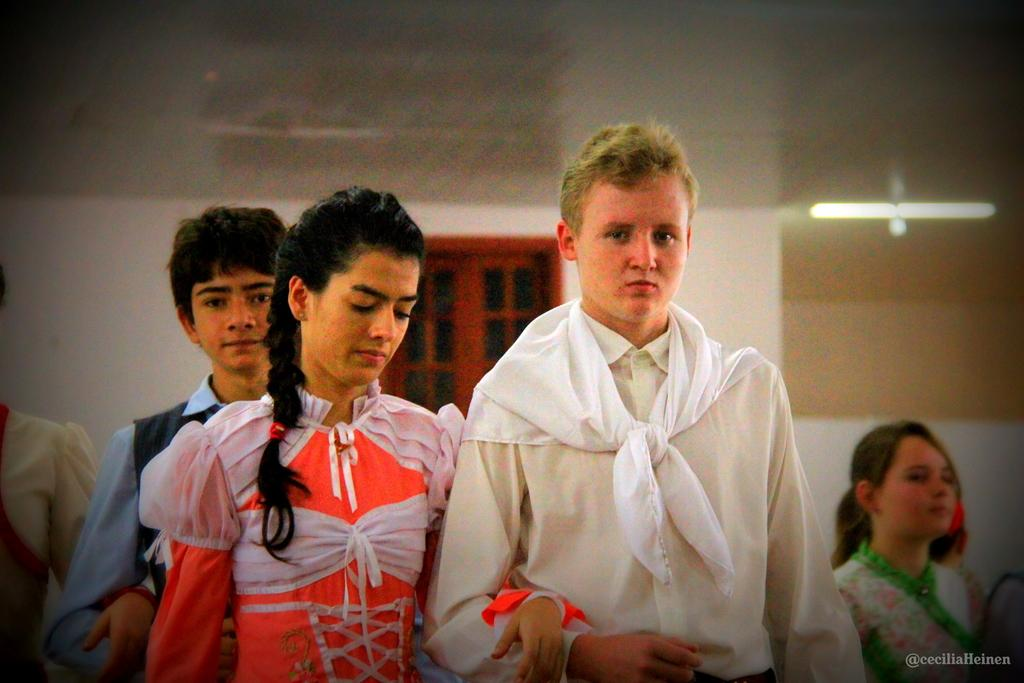What can be seen at the bottom of the image? There are persons in different colored dresses at the bottom of the image. Is there any text or logo visible in the image? Yes, there is a watermark on the bottom right of the image. What is visible in the background of the image? There is a window, a light, and a wall in the background of the image. Can you tell me how many faucets are visible in the image? There are no faucets present in the image. What type of wrist accessory is worn by the person on the left side of the image? There is no wrist accessory visible on any person in the image. 